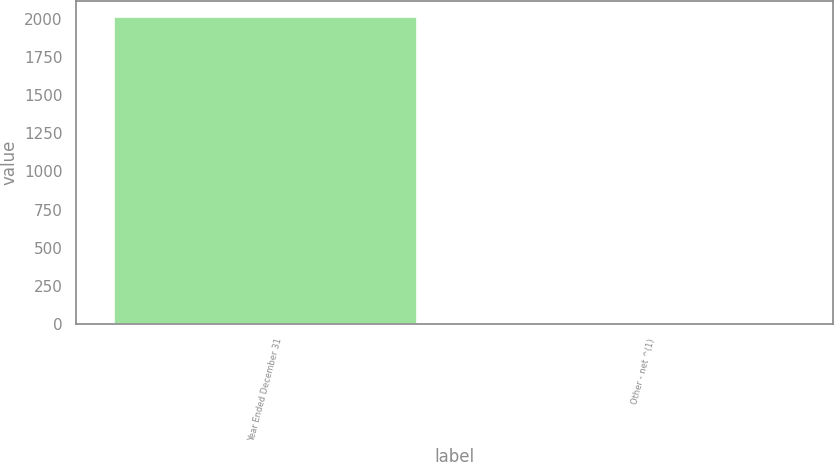Convert chart. <chart><loc_0><loc_0><loc_500><loc_500><bar_chart><fcel>Year Ended December 31<fcel>Other - net ^(1)<nl><fcel>2013<fcel>1<nl></chart> 